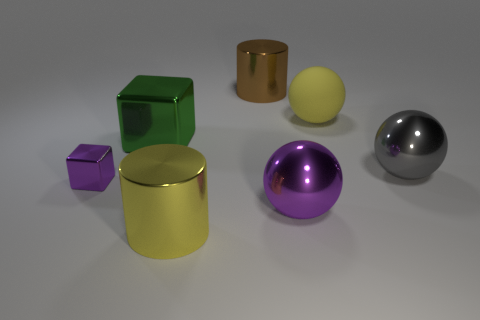What size is the other object that is the same color as the tiny object?
Your response must be concise. Large. There is a tiny shiny thing that is the same shape as the large green object; what color is it?
Provide a succinct answer. Purple. What color is the other rubber sphere that is the same size as the gray sphere?
Make the answer very short. Yellow. Does the brown cylinder have the same material as the small purple object?
Your answer should be compact. Yes. What number of tiny objects have the same color as the large cube?
Ensure brevity in your answer.  0. Is the color of the tiny cube the same as the large matte object?
Ensure brevity in your answer.  No. There is a large sphere behind the green cube; what is it made of?
Keep it short and to the point. Rubber. What number of large things are green blocks or metallic things?
Provide a short and direct response. 5. There is a cylinder that is the same color as the big matte sphere; what is its material?
Your answer should be compact. Metal. Is there a big green cube made of the same material as the tiny block?
Provide a succinct answer. Yes. 